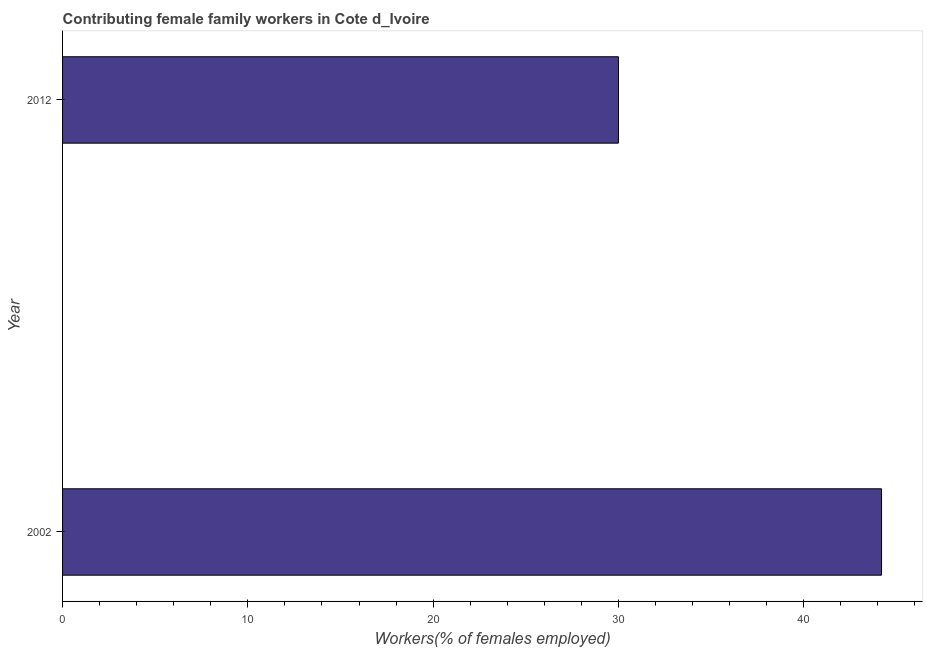Does the graph contain any zero values?
Your answer should be very brief. No. What is the title of the graph?
Offer a very short reply. Contributing female family workers in Cote d_Ivoire. What is the label or title of the X-axis?
Provide a succinct answer. Workers(% of females employed). What is the label or title of the Y-axis?
Keep it short and to the point. Year. What is the contributing female family workers in 2002?
Keep it short and to the point. 44.2. Across all years, what is the maximum contributing female family workers?
Your answer should be compact. 44.2. Across all years, what is the minimum contributing female family workers?
Give a very brief answer. 30. In which year was the contributing female family workers maximum?
Keep it short and to the point. 2002. In which year was the contributing female family workers minimum?
Provide a succinct answer. 2012. What is the sum of the contributing female family workers?
Offer a very short reply. 74.2. What is the difference between the contributing female family workers in 2002 and 2012?
Offer a terse response. 14.2. What is the average contributing female family workers per year?
Make the answer very short. 37.1. What is the median contributing female family workers?
Offer a very short reply. 37.1. In how many years, is the contributing female family workers greater than 38 %?
Provide a short and direct response. 1. Do a majority of the years between 2002 and 2012 (inclusive) have contributing female family workers greater than 40 %?
Make the answer very short. No. What is the ratio of the contributing female family workers in 2002 to that in 2012?
Make the answer very short. 1.47. Are all the bars in the graph horizontal?
Give a very brief answer. Yes. How many years are there in the graph?
Provide a short and direct response. 2. What is the Workers(% of females employed) of 2002?
Keep it short and to the point. 44.2. What is the difference between the Workers(% of females employed) in 2002 and 2012?
Offer a very short reply. 14.2. What is the ratio of the Workers(% of females employed) in 2002 to that in 2012?
Ensure brevity in your answer.  1.47. 